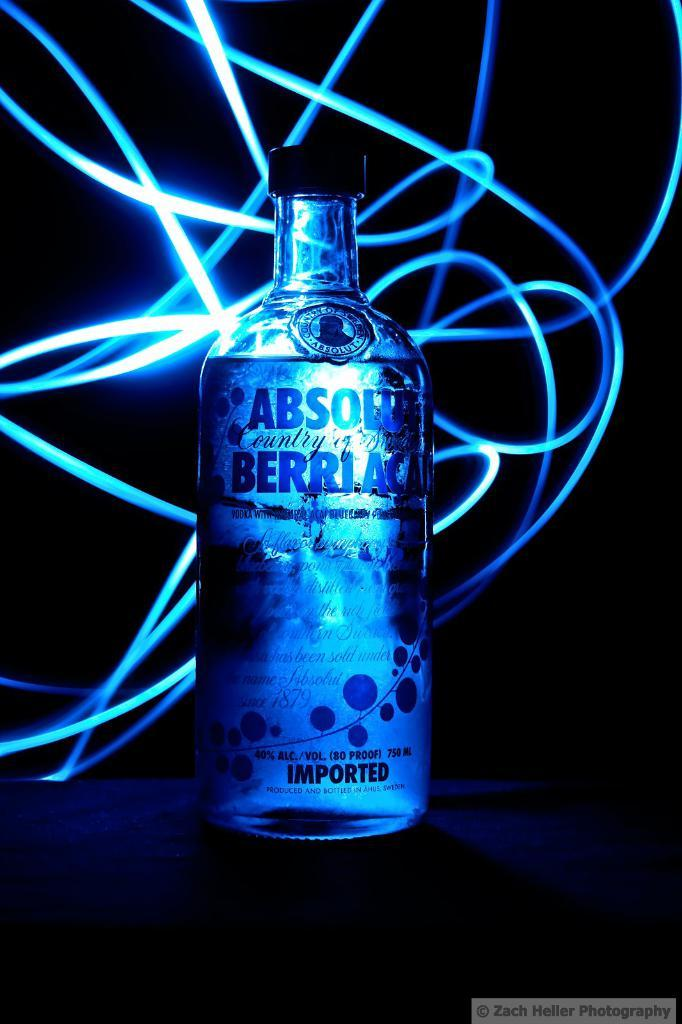<image>
Share a concise interpretation of the image provided. a bottle of imported absolut berriaca vodka 1879 